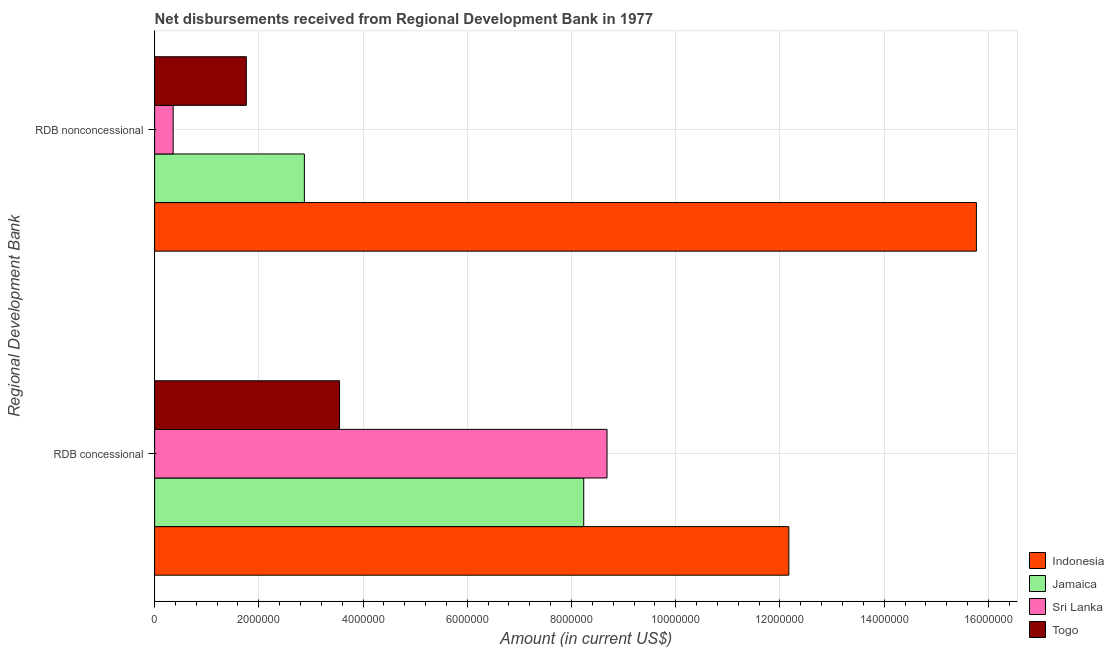How many different coloured bars are there?
Keep it short and to the point. 4. How many bars are there on the 1st tick from the top?
Offer a terse response. 4. What is the label of the 2nd group of bars from the top?
Provide a succinct answer. RDB concessional. What is the net concessional disbursements from rdb in Sri Lanka?
Keep it short and to the point. 8.68e+06. Across all countries, what is the maximum net non concessional disbursements from rdb?
Give a very brief answer. 1.58e+07. Across all countries, what is the minimum net non concessional disbursements from rdb?
Provide a short and direct response. 3.56e+05. In which country was the net concessional disbursements from rdb maximum?
Offer a very short reply. Indonesia. In which country was the net concessional disbursements from rdb minimum?
Ensure brevity in your answer.  Togo. What is the total net concessional disbursements from rdb in the graph?
Give a very brief answer. 3.26e+07. What is the difference between the net concessional disbursements from rdb in Jamaica and that in Togo?
Your response must be concise. 4.69e+06. What is the difference between the net non concessional disbursements from rdb in Indonesia and the net concessional disbursements from rdb in Sri Lanka?
Give a very brief answer. 7.09e+06. What is the average net non concessional disbursements from rdb per country?
Your response must be concise. 5.19e+06. What is the difference between the net concessional disbursements from rdb and net non concessional disbursements from rdb in Togo?
Your answer should be compact. 1.79e+06. What is the ratio of the net concessional disbursements from rdb in Jamaica to that in Sri Lanka?
Give a very brief answer. 0.95. Is the net non concessional disbursements from rdb in Togo less than that in Jamaica?
Provide a succinct answer. Yes. In how many countries, is the net non concessional disbursements from rdb greater than the average net non concessional disbursements from rdb taken over all countries?
Provide a succinct answer. 1. What does the 1st bar from the top in RDB concessional represents?
Make the answer very short. Togo. What does the 3rd bar from the bottom in RDB nonconcessional represents?
Offer a terse response. Sri Lanka. Are all the bars in the graph horizontal?
Give a very brief answer. Yes. How many countries are there in the graph?
Make the answer very short. 4. What is the difference between two consecutive major ticks on the X-axis?
Keep it short and to the point. 2.00e+06. Are the values on the major ticks of X-axis written in scientific E-notation?
Give a very brief answer. No. Where does the legend appear in the graph?
Ensure brevity in your answer.  Bottom right. How many legend labels are there?
Give a very brief answer. 4. What is the title of the graph?
Keep it short and to the point. Net disbursements received from Regional Development Bank in 1977. Does "Middle East & North Africa (all income levels)" appear as one of the legend labels in the graph?
Ensure brevity in your answer.  No. What is the label or title of the Y-axis?
Your answer should be very brief. Regional Development Bank. What is the Amount (in current US$) in Indonesia in RDB concessional?
Give a very brief answer. 1.22e+07. What is the Amount (in current US$) in Jamaica in RDB concessional?
Provide a short and direct response. 8.24e+06. What is the Amount (in current US$) of Sri Lanka in RDB concessional?
Give a very brief answer. 8.68e+06. What is the Amount (in current US$) of Togo in RDB concessional?
Ensure brevity in your answer.  3.55e+06. What is the Amount (in current US$) in Indonesia in RDB nonconcessional?
Your answer should be very brief. 1.58e+07. What is the Amount (in current US$) of Jamaica in RDB nonconcessional?
Your answer should be very brief. 2.87e+06. What is the Amount (in current US$) in Sri Lanka in RDB nonconcessional?
Your answer should be very brief. 3.56e+05. What is the Amount (in current US$) in Togo in RDB nonconcessional?
Keep it short and to the point. 1.76e+06. Across all Regional Development Bank, what is the maximum Amount (in current US$) in Indonesia?
Provide a succinct answer. 1.58e+07. Across all Regional Development Bank, what is the maximum Amount (in current US$) in Jamaica?
Make the answer very short. 8.24e+06. Across all Regional Development Bank, what is the maximum Amount (in current US$) of Sri Lanka?
Your answer should be compact. 8.68e+06. Across all Regional Development Bank, what is the maximum Amount (in current US$) of Togo?
Provide a succinct answer. 3.55e+06. Across all Regional Development Bank, what is the minimum Amount (in current US$) of Indonesia?
Ensure brevity in your answer.  1.22e+07. Across all Regional Development Bank, what is the minimum Amount (in current US$) of Jamaica?
Make the answer very short. 2.87e+06. Across all Regional Development Bank, what is the minimum Amount (in current US$) of Sri Lanka?
Offer a very short reply. 3.56e+05. Across all Regional Development Bank, what is the minimum Amount (in current US$) in Togo?
Offer a very short reply. 1.76e+06. What is the total Amount (in current US$) in Indonesia in the graph?
Offer a very short reply. 2.79e+07. What is the total Amount (in current US$) of Jamaica in the graph?
Give a very brief answer. 1.11e+07. What is the total Amount (in current US$) of Sri Lanka in the graph?
Provide a short and direct response. 9.04e+06. What is the total Amount (in current US$) in Togo in the graph?
Your answer should be very brief. 5.31e+06. What is the difference between the Amount (in current US$) in Indonesia in RDB concessional and that in RDB nonconcessional?
Your response must be concise. -3.60e+06. What is the difference between the Amount (in current US$) of Jamaica in RDB concessional and that in RDB nonconcessional?
Make the answer very short. 5.36e+06. What is the difference between the Amount (in current US$) of Sri Lanka in RDB concessional and that in RDB nonconcessional?
Provide a short and direct response. 8.33e+06. What is the difference between the Amount (in current US$) of Togo in RDB concessional and that in RDB nonconcessional?
Provide a short and direct response. 1.79e+06. What is the difference between the Amount (in current US$) of Indonesia in RDB concessional and the Amount (in current US$) of Jamaica in RDB nonconcessional?
Provide a short and direct response. 9.30e+06. What is the difference between the Amount (in current US$) of Indonesia in RDB concessional and the Amount (in current US$) of Sri Lanka in RDB nonconcessional?
Provide a succinct answer. 1.18e+07. What is the difference between the Amount (in current US$) of Indonesia in RDB concessional and the Amount (in current US$) of Togo in RDB nonconcessional?
Make the answer very short. 1.04e+07. What is the difference between the Amount (in current US$) of Jamaica in RDB concessional and the Amount (in current US$) of Sri Lanka in RDB nonconcessional?
Offer a terse response. 7.88e+06. What is the difference between the Amount (in current US$) in Jamaica in RDB concessional and the Amount (in current US$) in Togo in RDB nonconcessional?
Provide a short and direct response. 6.48e+06. What is the difference between the Amount (in current US$) in Sri Lanka in RDB concessional and the Amount (in current US$) in Togo in RDB nonconcessional?
Provide a short and direct response. 6.92e+06. What is the average Amount (in current US$) in Indonesia per Regional Development Bank?
Your answer should be compact. 1.40e+07. What is the average Amount (in current US$) in Jamaica per Regional Development Bank?
Provide a succinct answer. 5.55e+06. What is the average Amount (in current US$) in Sri Lanka per Regional Development Bank?
Give a very brief answer. 4.52e+06. What is the average Amount (in current US$) of Togo per Regional Development Bank?
Your answer should be compact. 2.65e+06. What is the difference between the Amount (in current US$) of Indonesia and Amount (in current US$) of Jamaica in RDB concessional?
Keep it short and to the point. 3.94e+06. What is the difference between the Amount (in current US$) of Indonesia and Amount (in current US$) of Sri Lanka in RDB concessional?
Provide a succinct answer. 3.49e+06. What is the difference between the Amount (in current US$) in Indonesia and Amount (in current US$) in Togo in RDB concessional?
Your answer should be very brief. 8.62e+06. What is the difference between the Amount (in current US$) in Jamaica and Amount (in current US$) in Sri Lanka in RDB concessional?
Give a very brief answer. -4.47e+05. What is the difference between the Amount (in current US$) of Jamaica and Amount (in current US$) of Togo in RDB concessional?
Keep it short and to the point. 4.69e+06. What is the difference between the Amount (in current US$) in Sri Lanka and Amount (in current US$) in Togo in RDB concessional?
Make the answer very short. 5.13e+06. What is the difference between the Amount (in current US$) in Indonesia and Amount (in current US$) in Jamaica in RDB nonconcessional?
Ensure brevity in your answer.  1.29e+07. What is the difference between the Amount (in current US$) of Indonesia and Amount (in current US$) of Sri Lanka in RDB nonconcessional?
Offer a terse response. 1.54e+07. What is the difference between the Amount (in current US$) of Indonesia and Amount (in current US$) of Togo in RDB nonconcessional?
Offer a terse response. 1.40e+07. What is the difference between the Amount (in current US$) in Jamaica and Amount (in current US$) in Sri Lanka in RDB nonconcessional?
Your answer should be very brief. 2.52e+06. What is the difference between the Amount (in current US$) of Jamaica and Amount (in current US$) of Togo in RDB nonconcessional?
Provide a succinct answer. 1.11e+06. What is the difference between the Amount (in current US$) in Sri Lanka and Amount (in current US$) in Togo in RDB nonconcessional?
Ensure brevity in your answer.  -1.40e+06. What is the ratio of the Amount (in current US$) in Indonesia in RDB concessional to that in RDB nonconcessional?
Make the answer very short. 0.77. What is the ratio of the Amount (in current US$) of Jamaica in RDB concessional to that in RDB nonconcessional?
Give a very brief answer. 2.87. What is the ratio of the Amount (in current US$) of Sri Lanka in RDB concessional to that in RDB nonconcessional?
Offer a terse response. 24.39. What is the ratio of the Amount (in current US$) in Togo in RDB concessional to that in RDB nonconcessional?
Offer a very short reply. 2.02. What is the difference between the highest and the second highest Amount (in current US$) in Indonesia?
Offer a terse response. 3.60e+06. What is the difference between the highest and the second highest Amount (in current US$) in Jamaica?
Keep it short and to the point. 5.36e+06. What is the difference between the highest and the second highest Amount (in current US$) in Sri Lanka?
Make the answer very short. 8.33e+06. What is the difference between the highest and the second highest Amount (in current US$) of Togo?
Make the answer very short. 1.79e+06. What is the difference between the highest and the lowest Amount (in current US$) of Indonesia?
Provide a short and direct response. 3.60e+06. What is the difference between the highest and the lowest Amount (in current US$) in Jamaica?
Make the answer very short. 5.36e+06. What is the difference between the highest and the lowest Amount (in current US$) of Sri Lanka?
Offer a terse response. 8.33e+06. What is the difference between the highest and the lowest Amount (in current US$) in Togo?
Keep it short and to the point. 1.79e+06. 